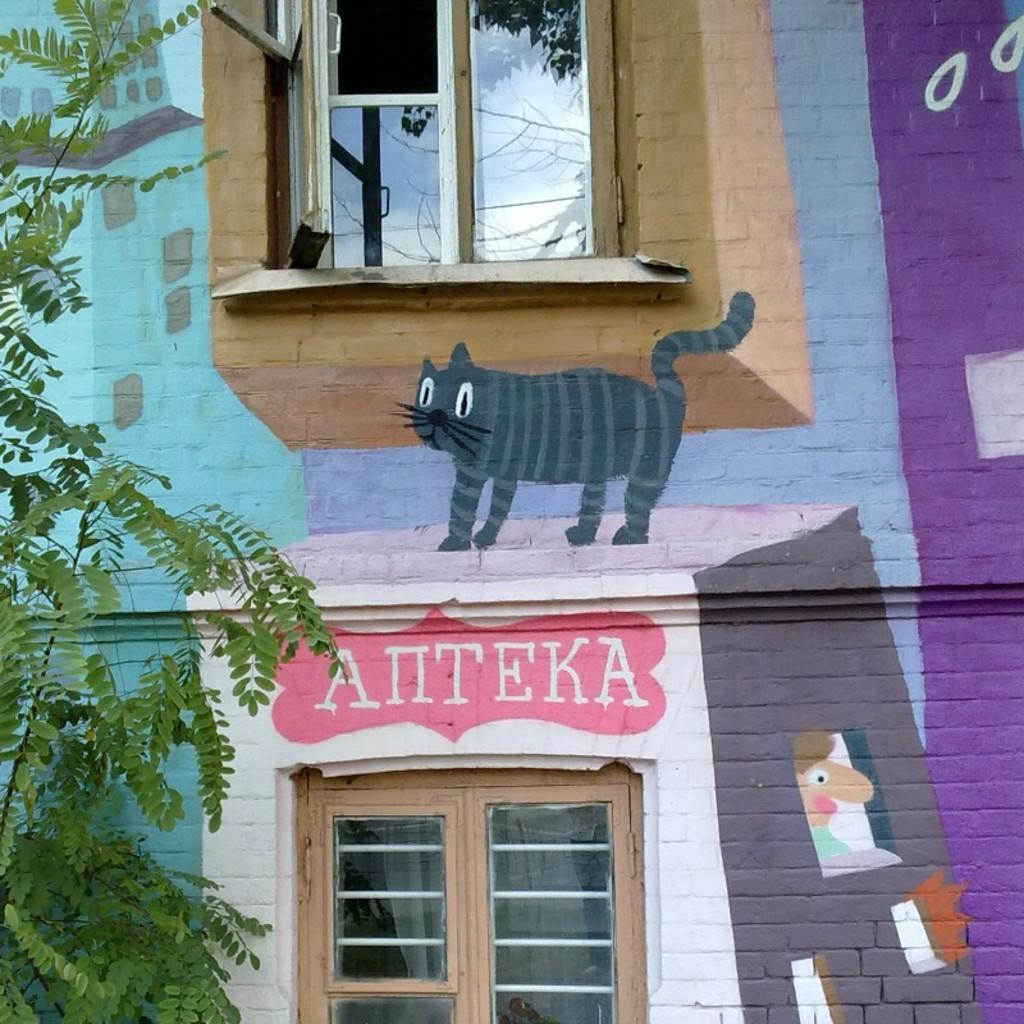What is located on the left side of the image? There is a tree on the left side of the image. What can be seen on the building in the image? There is a painting and text on the building. What type of watch is hanging from the tree in the image? There is no watch present in the image; it features a tree, a building with a painting and text, but no watch. What kind of stamp can be seen on the painting? There is no stamp visible on the painting in the image. 